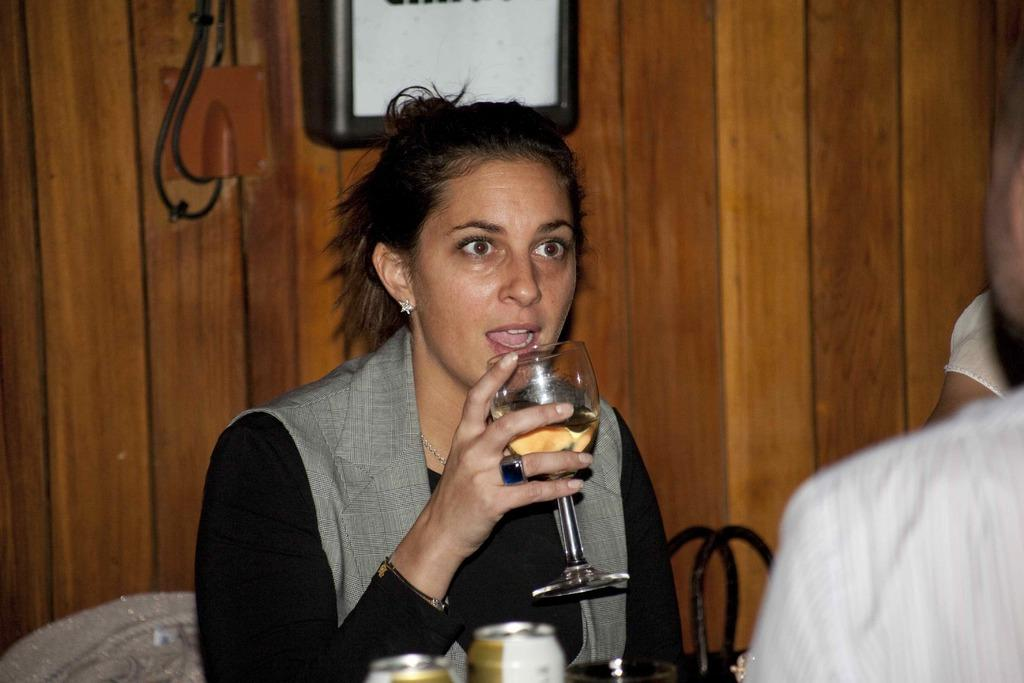Who is present in the image? There is a woman in the picture. What is the woman holding in her hand? The woman is holding a drinking glass in her hand. Can you describe the man in the picture? There is a partial view of a man on the right side of the picture. What type of toothbrush is the monkey using in the image? There is no monkey or toothbrush present in the image. 